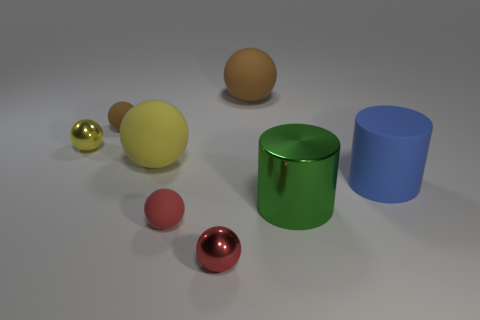Are there any things that have the same size as the metallic cylinder?
Your answer should be compact. Yes. What is the material of the large object to the left of the large brown rubber sphere?
Give a very brief answer. Rubber. Is the yellow sphere in front of the small yellow object made of the same material as the green thing?
Keep it short and to the point. No. Are any metallic cubes visible?
Make the answer very short. No. What is the color of the cylinder that is the same material as the large brown thing?
Keep it short and to the point. Blue. There is a metal ball on the left side of the brown ball that is in front of the large thing that is behind the tiny yellow sphere; what color is it?
Keep it short and to the point. Yellow. Is the size of the blue rubber thing the same as the metal object right of the big brown object?
Give a very brief answer. Yes. What number of objects are large matte things on the right side of the shiny cylinder or small objects that are in front of the blue cylinder?
Make the answer very short. 3. What is the shape of the yellow matte thing that is the same size as the blue thing?
Ensure brevity in your answer.  Sphere. What is the shape of the shiny object behind the yellow ball to the right of the yellow sphere behind the big yellow matte sphere?
Keep it short and to the point. Sphere. 